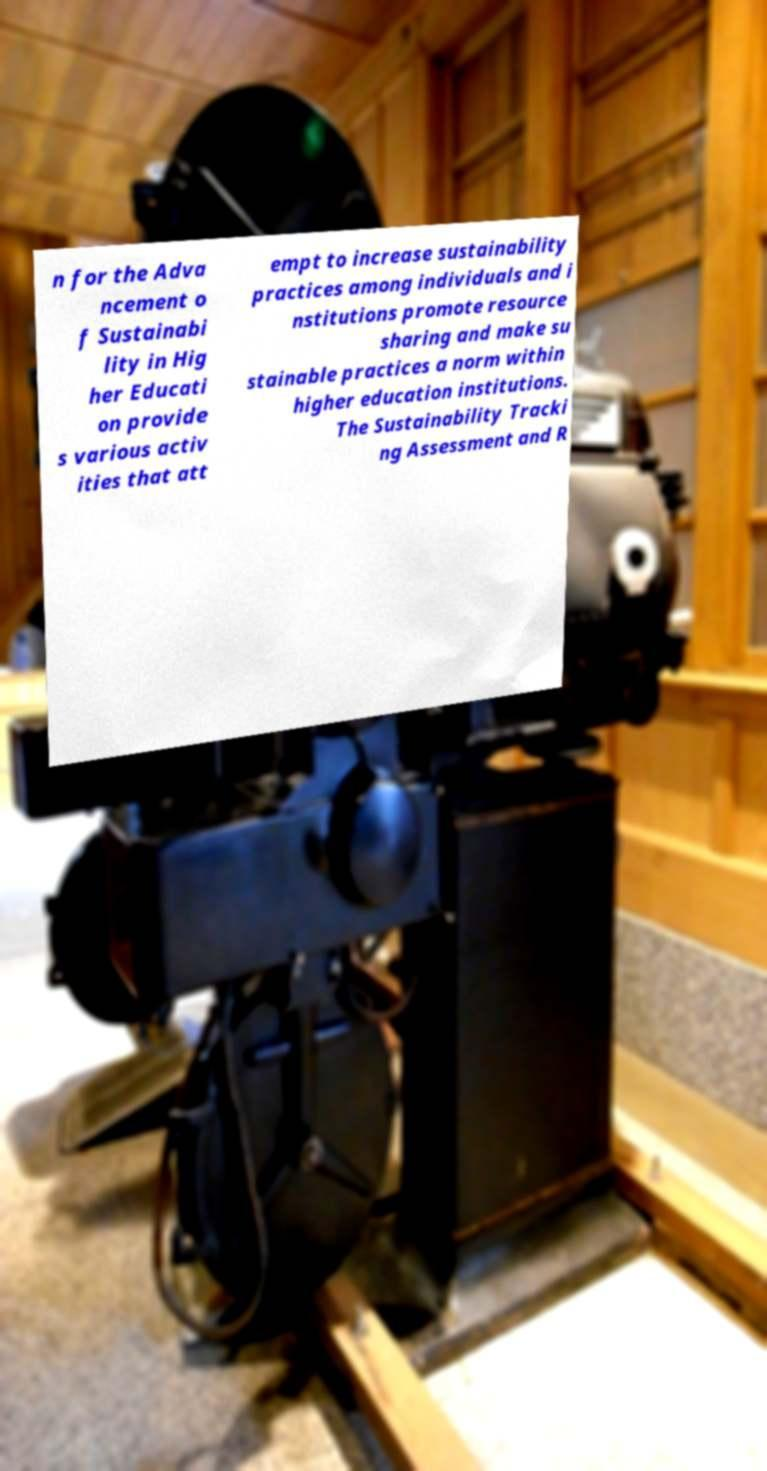Could you assist in decoding the text presented in this image and type it out clearly? n for the Adva ncement o f Sustainabi lity in Hig her Educati on provide s various activ ities that att empt to increase sustainability practices among individuals and i nstitutions promote resource sharing and make su stainable practices a norm within higher education institutions. The Sustainability Tracki ng Assessment and R 